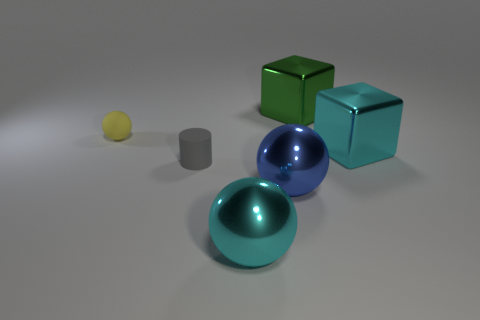Add 2 matte cylinders. How many objects exist? 8 Subtract all blocks. How many objects are left? 4 Add 6 cylinders. How many cylinders are left? 7 Add 1 large green shiny objects. How many large green shiny objects exist? 2 Subtract 1 green cubes. How many objects are left? 5 Subtract all blue spheres. Subtract all large purple metallic cylinders. How many objects are left? 5 